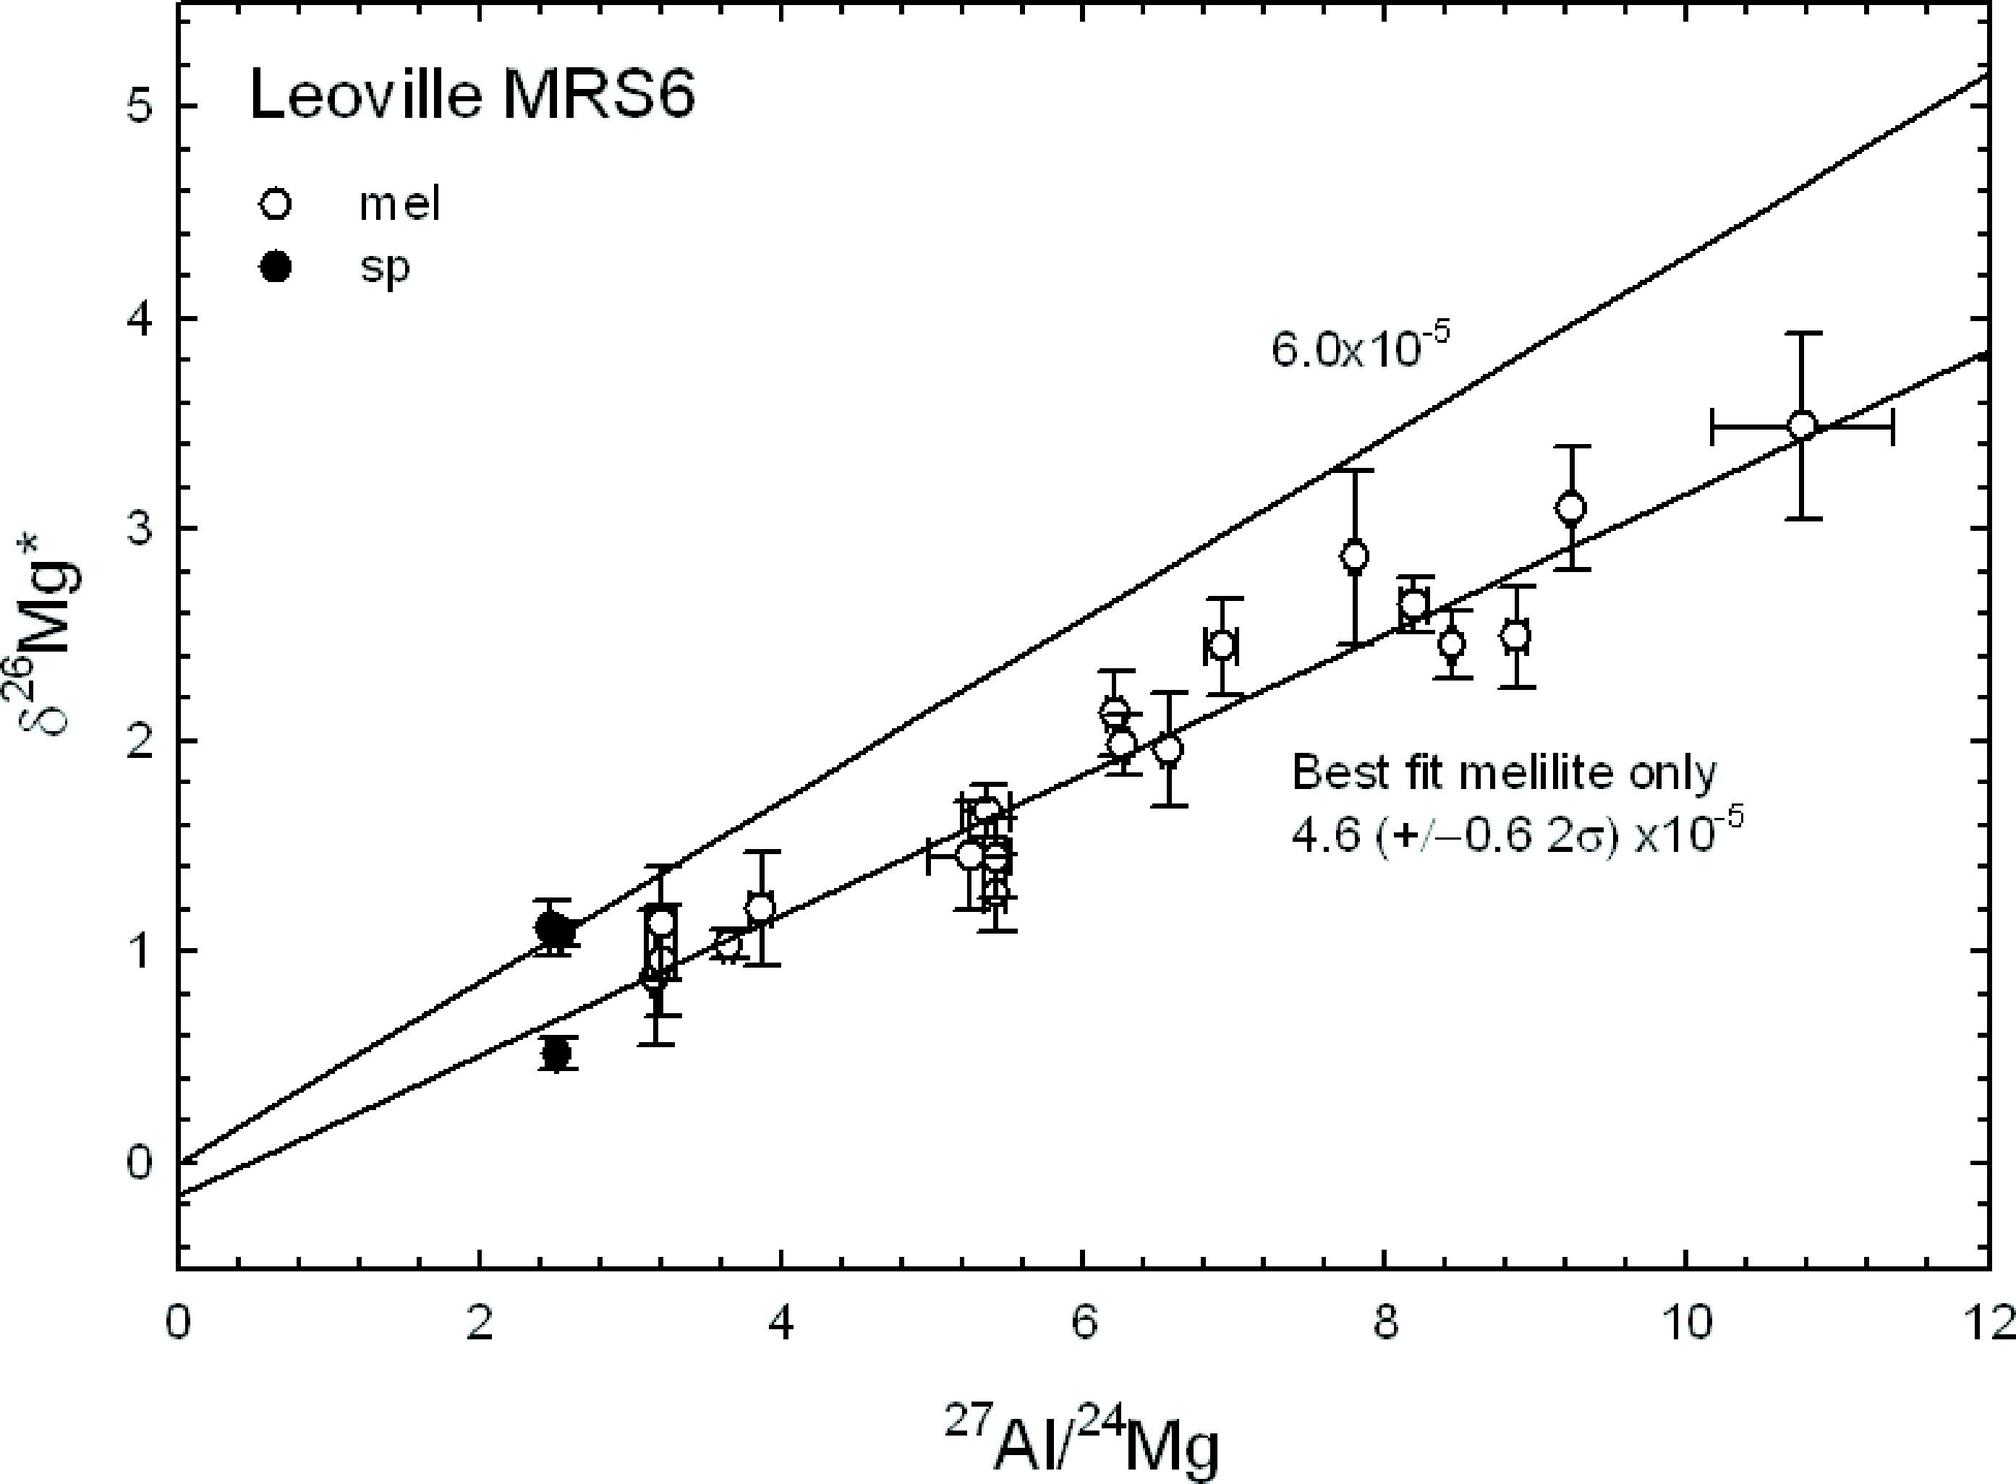Could you elaborate on the significance of the data range and error bars shown on the graph? The data range and error bars on the graph are indicative of the experimental measurements' variability and precision. Each error bar represents the confidence interval around each data point, showing the potential variability of \u03b426Mg* measurements. A wider error bar suggests greater uncertainty in the measurement, possibly due to sample heterogeneity or measurement technique limitations. Understanding these variances is crucial for interpreting the data reliability and ensuring that conclusions drawn from the graph are robust and statistically significant. 